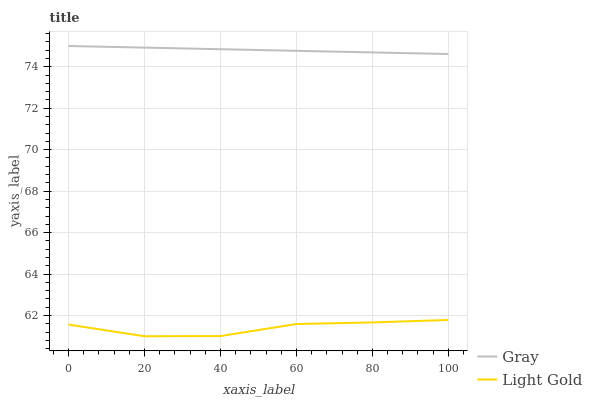Does Light Gold have the minimum area under the curve?
Answer yes or no. Yes. Does Gray have the maximum area under the curve?
Answer yes or no. Yes. Does Light Gold have the maximum area under the curve?
Answer yes or no. No. Is Gray the smoothest?
Answer yes or no. Yes. Is Light Gold the roughest?
Answer yes or no. Yes. Is Light Gold the smoothest?
Answer yes or no. No. Does Light Gold have the lowest value?
Answer yes or no. Yes. Does Gray have the highest value?
Answer yes or no. Yes. Does Light Gold have the highest value?
Answer yes or no. No. Is Light Gold less than Gray?
Answer yes or no. Yes. Is Gray greater than Light Gold?
Answer yes or no. Yes. Does Light Gold intersect Gray?
Answer yes or no. No. 